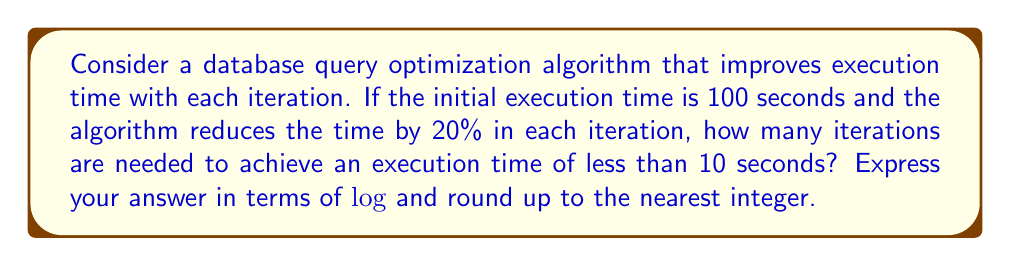What is the answer to this math problem? Let's approach this step-by-step:

1) Let $t_n$ be the execution time after $n$ iterations. We can express this as:

   $t_n = 100 \cdot (0.8)^n$

   This is because each iteration reduces the time by 20%, or multiplies it by 0.8.

2) We want to find $n$ such that $t_n < 10$. So we need to solve:

   $100 \cdot (0.8)^n < 10$

3) Dividing both sides by 100:

   $(0.8)^n < 0.1$

4) Taking $\log$ of both sides (we can use any base, let's use base 10):

   $n \log(0.8) < \log(0.1)$

5) Dividing both sides by $\log(0.8)$ (note that $\log(0.8)$ is negative, so the inequality sign flips):

   $n > \frac{\log(0.1)}{\log(0.8)}$

6) Calculating this:

   $n > \frac{\log(0.1)}{\log(0.8)} \approx 10.32$

7) Since we need to round up to the nearest integer:

   $n = \left\lceil\frac{\log(0.1)}{\log(0.8)}\right\rceil = 11$

Therefore, 11 iterations are needed to achieve an execution time of less than 10 seconds.
Answer: $\left\lceil\frac{\log(0.1)}{\log(0.8)}\right\rceil = 11$ 